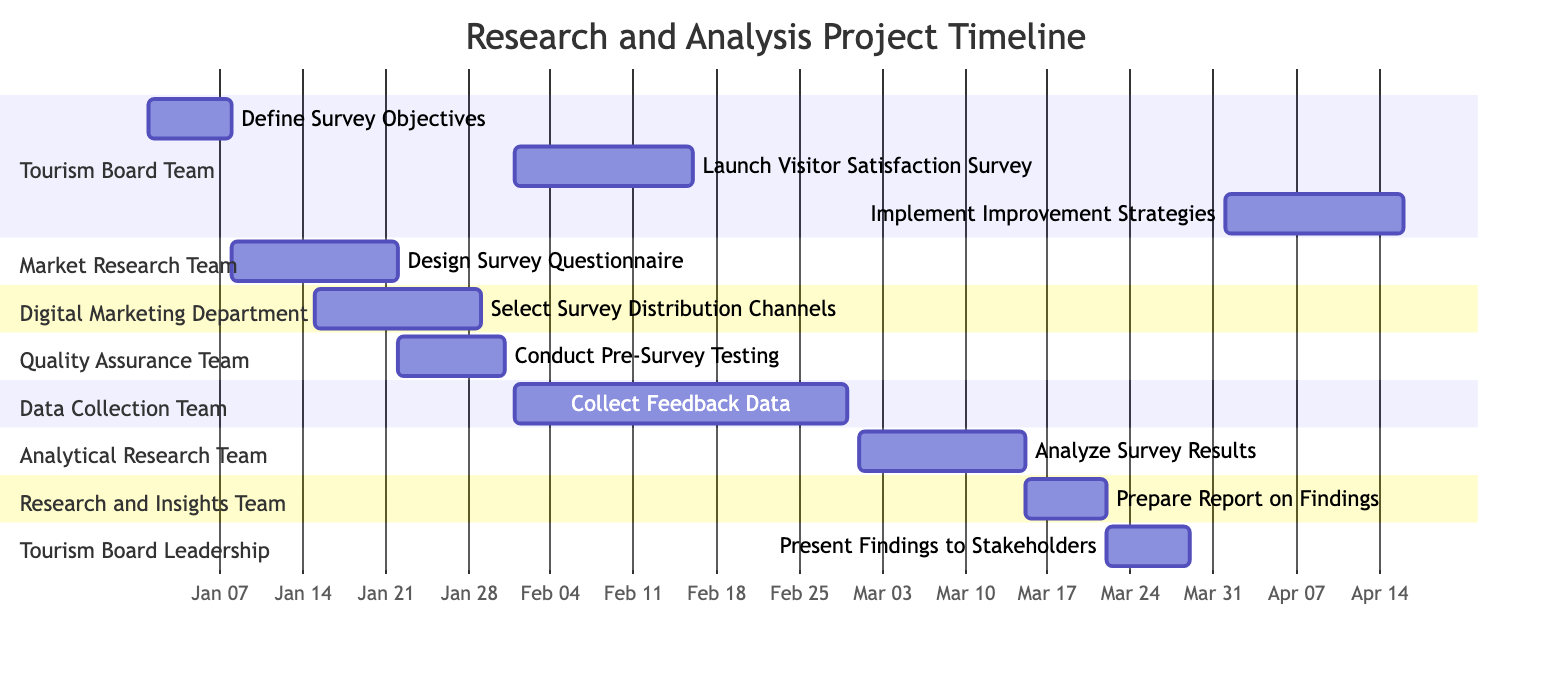What is the total number of tasks in this project timeline? The project timeline includes multiple tasks listed in various sections. Counting each individual task, there are ten in total.
Answer: 10 Which team is responsible for analyzing survey results? By looking at the Gantt chart, the task "Analyze Survey Results" is assigned to the "Analytical Research Team."
Answer: Analytical Research Team What is the duration for the "Design Survey Questionnaire" task? The task starts on January 8, 2024, and ends on January 21, 2024. Counting the days between these dates gives a duration of 14 days.
Answer: 14 days What task occurs immediately after the "Conduct Pre-Survey Testing"? The task "Launch Visitor Satisfaction Survey" starts right after "Conduct Pre-Survey Testing" concludes on January 30, 2024.
Answer: Launch Visitor Satisfaction Survey Which section has tasks scheduled for February 2024? The "Tourism Board Team" and "Data Collection Team" both have tasks scheduled, notably "Launch Visitor Satisfaction Survey" and "Collect Feedback Data."
Answer: Tourism Board Team, Data Collection Team How many days are allocated for data collection? The "Collect Feedback Data" task runs from February 1, 2024, to February 28, 2024. This gives a total duration of 28 days for data collection.
Answer: 28 days What is the start date for the "Prepare Report on Findings"? This task is set to start on March 15, 2024, according to the diagram.
Answer: March 15, 2024 Which team is working on designing the survey questionnaire? The task "Design Survey Questionnaire" is assigned to the "Market Research Team," as indicated in the chart.
Answer: Market Research Team When does the project officially begin? The first task "Define Survey Objectives" starts on January 1, 2024, marking the official start date of the entire project timeline.
Answer: January 1, 2024 